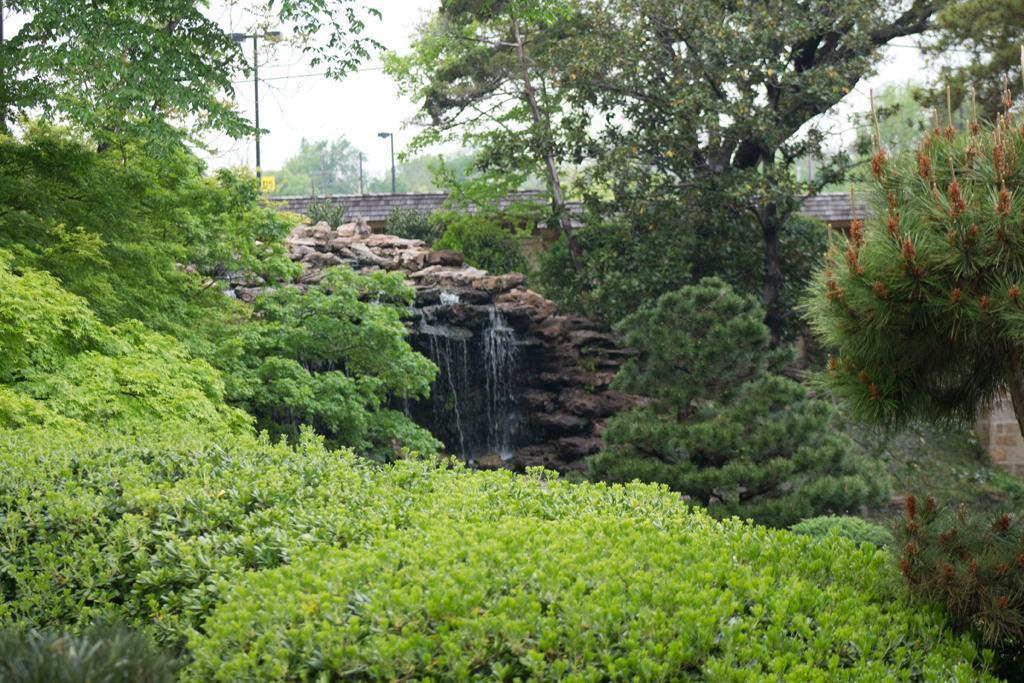What type of natural elements can be seen in the image? There are many trees, plants, and rocks visible in the image. What is the main water feature in the image? There is a waterfall in the image. What type of man-made structure is present in the image? There is a wall in the image. What can be seen in the background of the image? In the background, there are poles visible, a yellow object, and the sky. What type of writing can be seen on the jellyfish in the image? There are no jellyfish present in the image, so there is no writing on any jellyfish. 